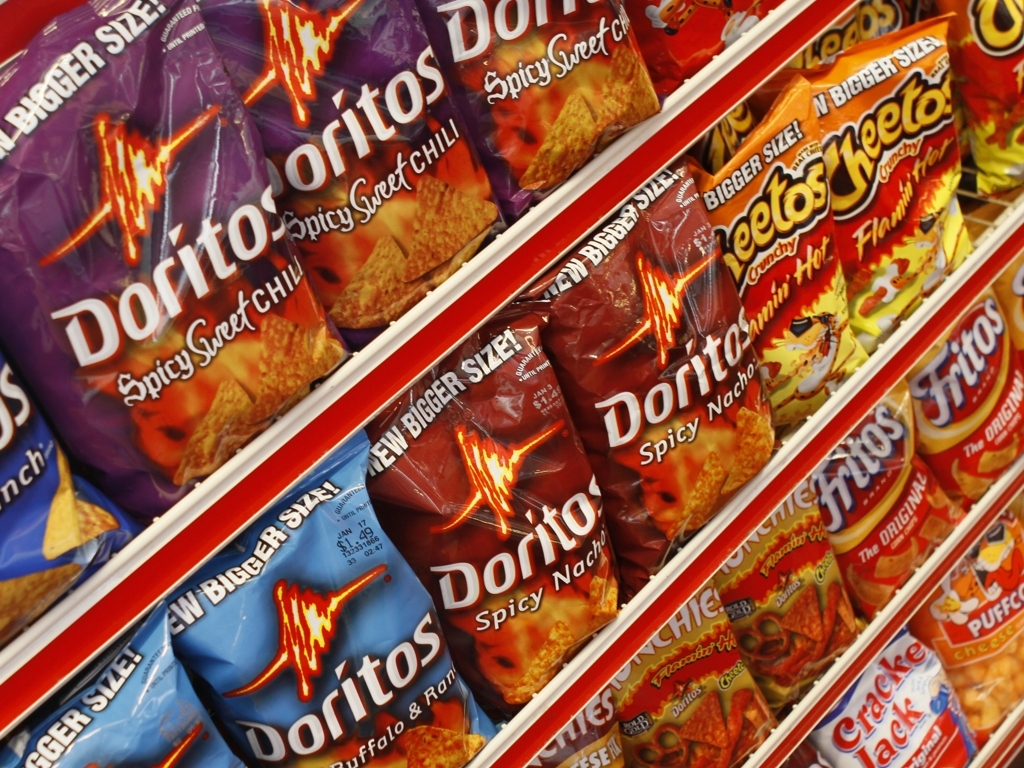What flavors of Doritos are visible in the image? The image shows two flavors of Doritos: Spicy Sweet Chili, which has a purple package, and Spicy Nacho, recognizable by its dark red packaging. 